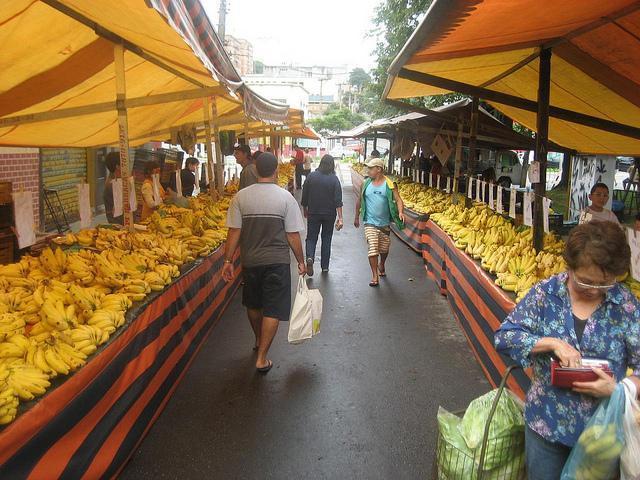How many people are visible?
Give a very brief answer. 4. 